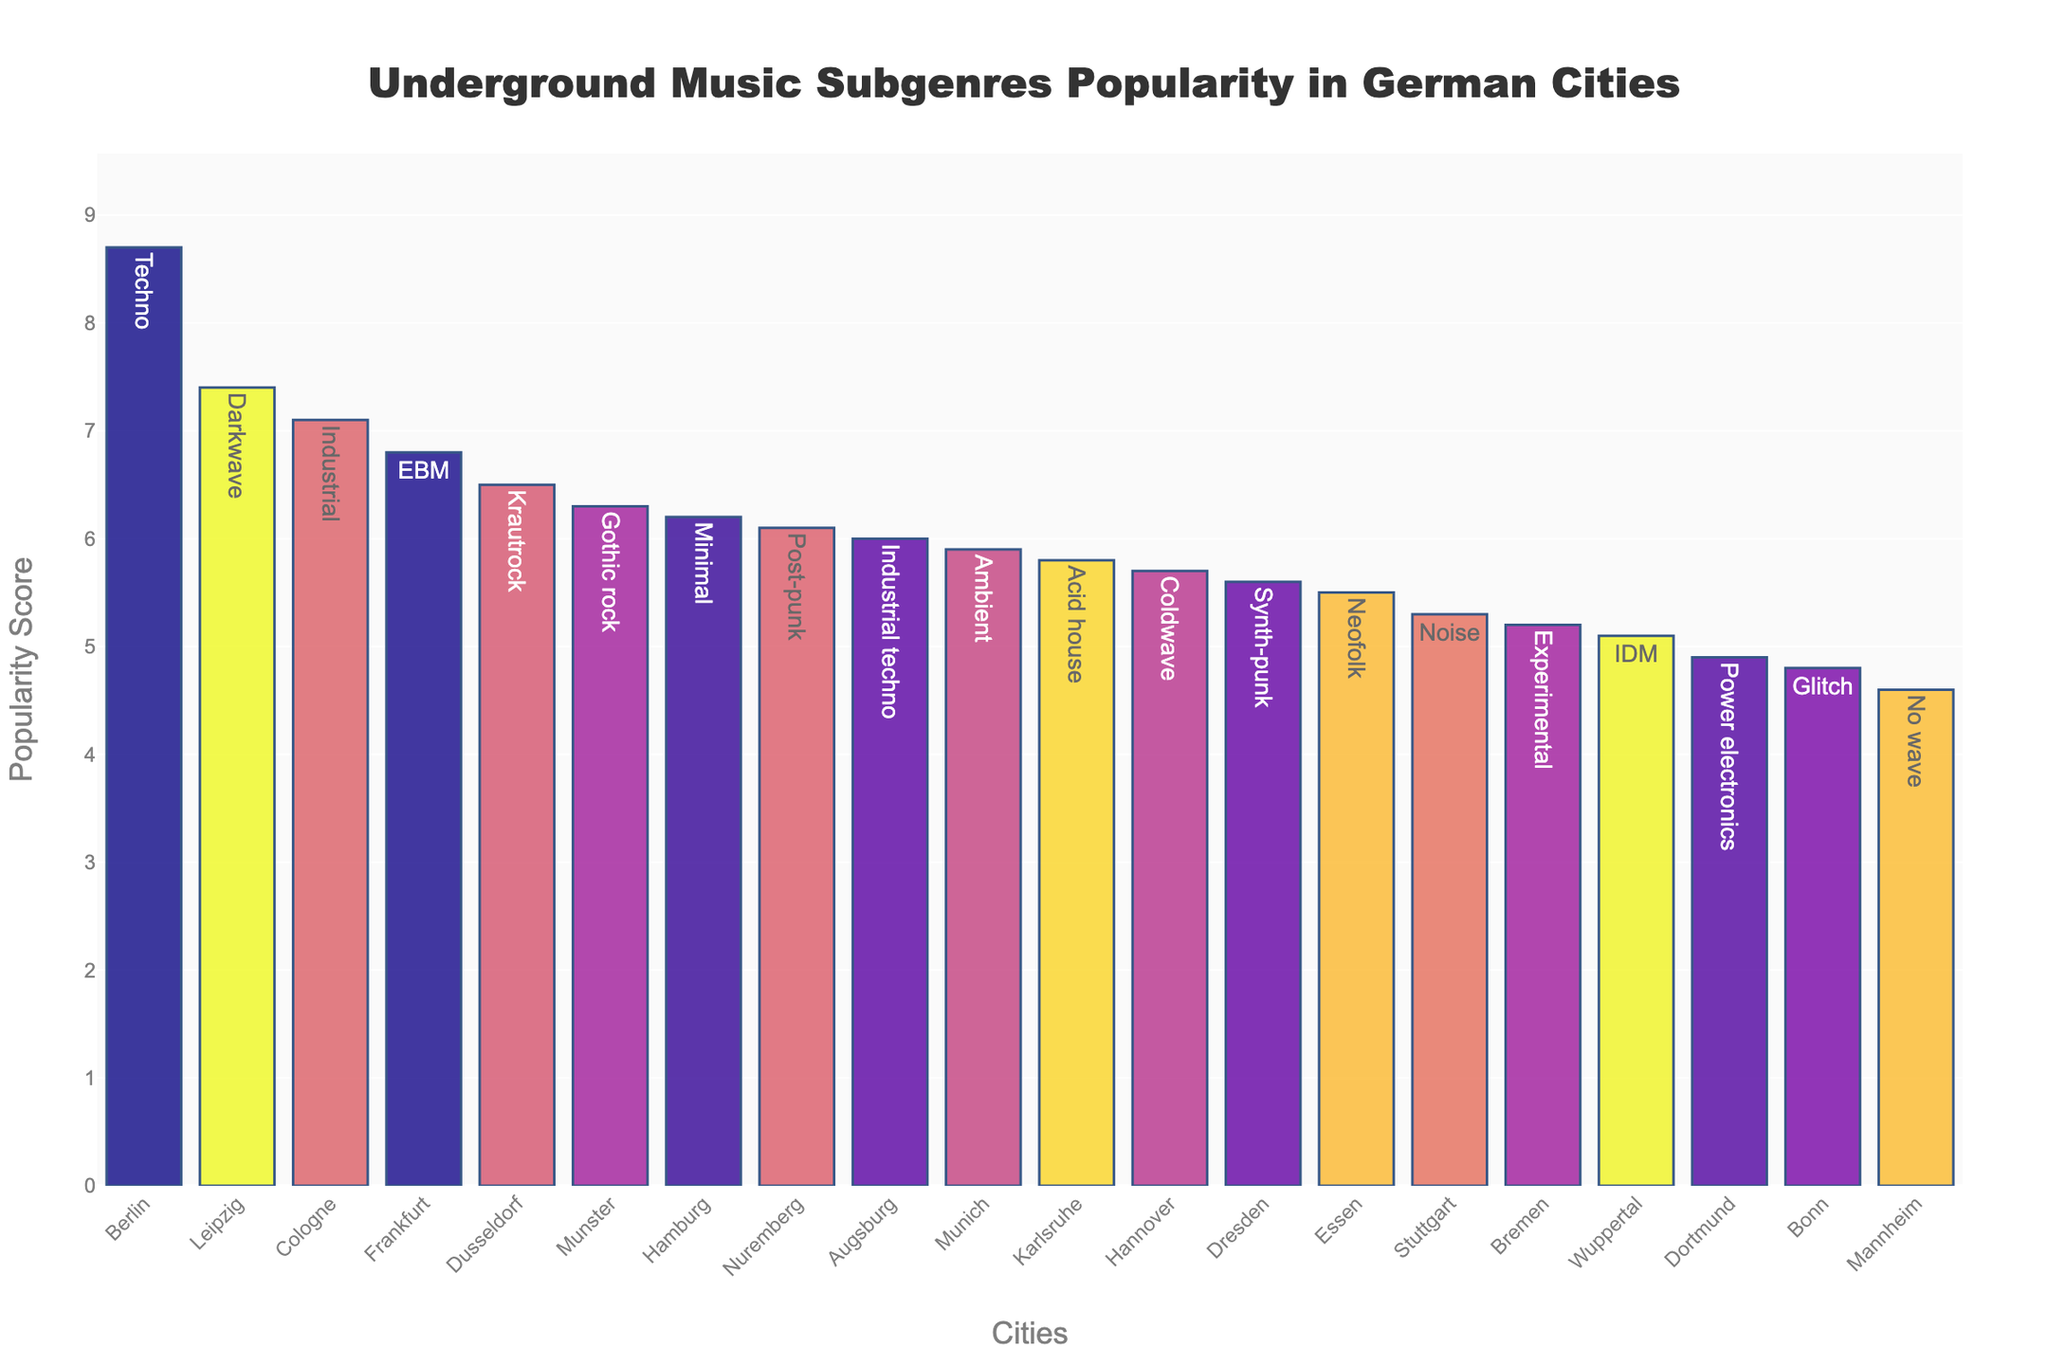Which city has the highest popularity score? Look at the bar with the highest value on the Y-axis. The city is labeled at the top along with the subgenre. In this case, the tallest bar is for Berlin with Techno having a popularity score of 8.7.
Answer: Berlin What is the average popularity score of all the cities? Sum all popularity scores and divide by the number of cities. Sum is 117.5, number of cities is 20. Average is 117.5/20 = 5.875
Answer: 5.88 Which subgenre is most popular in Leipzig? Find the bar corresponding to Leipzig on the X-axis and look at the label on top. Leipzig has Darkwave with a popularity score of 7.4.
Answer: Darkwave How much more popular is Techno in Berlin compared to Glitch in Bonn? Subtract the popularity score of Glitch from Techno. Techno's score is 8.7 and Glitch's score is 4.8. The difference is 8.7 - 4.8 = 3.9
Answer: 3.9 Which cities have a popularity score greater than 6.5 for any subgenre? Scan the Y-axis and identify bars with values greater than 6.5. These cities are Berlin, Leipzig, Cologne, Frankfurt, and Munster.
Answer: Berlin, Leipzig, Cologne, Frankfurt, Munster How many subgenres have a popularity score less than 5? Count the bars below the 5 mark on the Y-axis. There are four such subgenres: Power electronics in Dortmund, Glitch in Bonn, No wave in Mannheim, and IDM in Wuppertal.
Answer: 4 What's the total popularity score for the cities that have Techno and Industrial subgenres combined? Add up the popularity scores for cities listed with Techno and Industrial. Berlin has Techno (8.7), and Cologne has Industrial (7.1). Total is 8.7 + 7.1 = 15.8.
Answer: 15.8 Which city has the least popular subgenre? Find the shortest bar on the Y-axis. Mannheim has the shortest bar with the subgenre No wave and a score of 4.6.
Answer: Mannheim What's the combined popularity score of Ambient, Experimental, and Noise subgenres? Add the popularity scores for Munich (Ambient 5.9), Bremen (Experimental 5.2), and Stuttgart (Noise 5.3). Total is 5.9 + 5.2 + 5.3 = 16.4
Answer: 16.4 